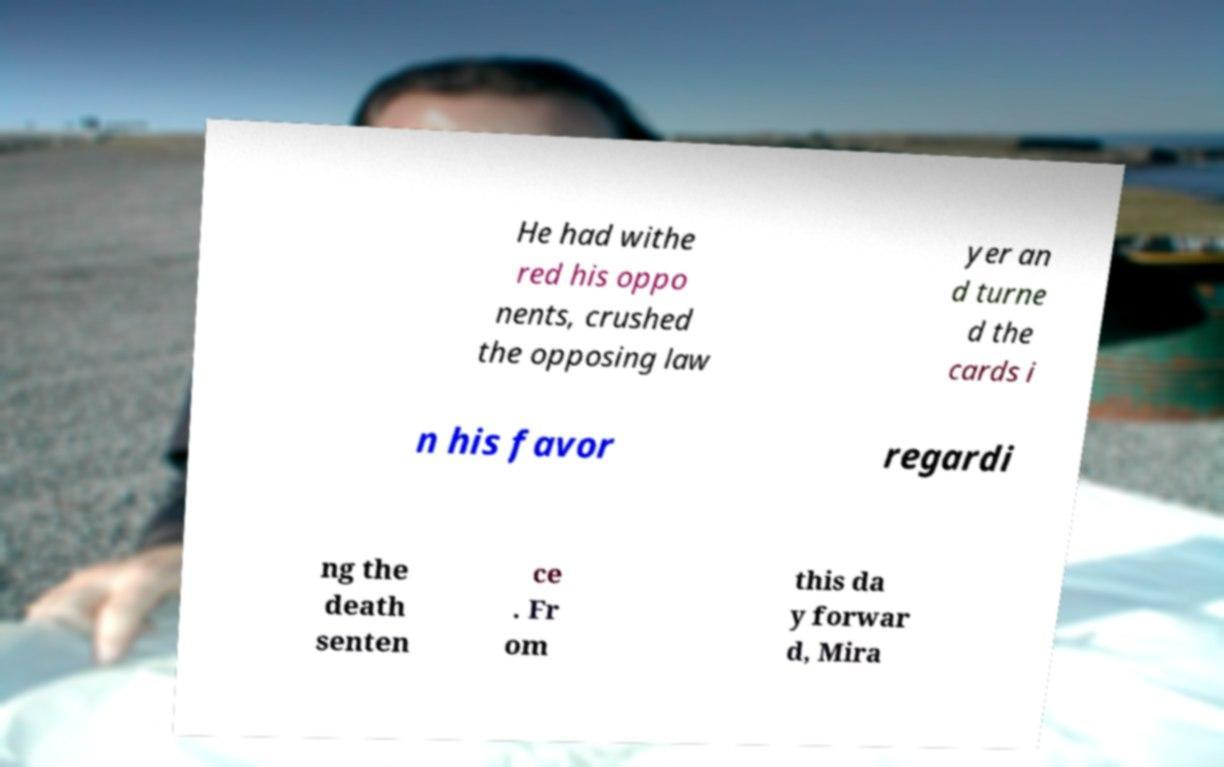Please identify and transcribe the text found in this image. He had withe red his oppo nents, crushed the opposing law yer an d turne d the cards i n his favor regardi ng the death senten ce . Fr om this da y forwar d, Mira 